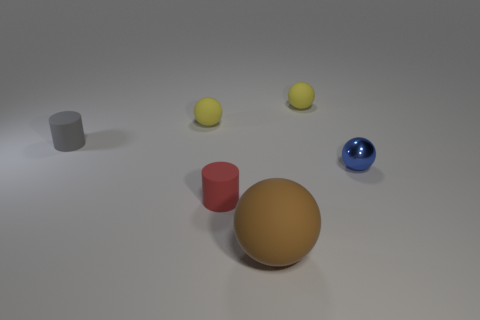If you were to describe this composition to someone who can't see it, what would you say? I'd describe this as a still life arrangement on a flat surface with neutral tones. The composition includes five objects, each with distinct shapes and colors. Foregrounded is a large, matte golden sphere. To its right, there is a smaller, highly reflective blue sphere. Center left features a short, small-diameter gray cylinder, and a taller, vibrant red cylinder is seen just behind the golden sphere. Finally, there are three identical smaller spheres in the back, which display a lemon yellow hue and matte texture. The overall setting is calm and orderly, with each object casting a soft shadow that confirms an even light source from above. 